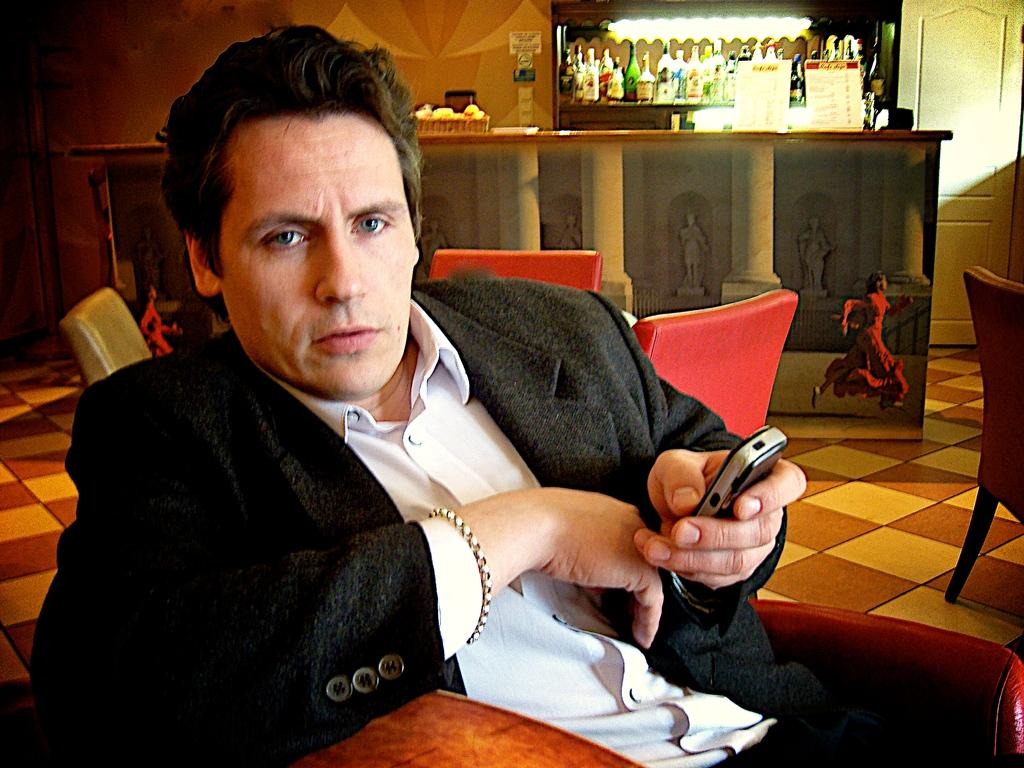What is the man in the image doing? The man is sitting on a sofa in the image. What is the man holding in his hand? The man is holding a mobile in his hand. What can be seen in the background of the image? There are empty chairs, a wall, and a table visible in the background of the image. What is on the table in the background? There is a group of bottles on the table. What type of lock is the minister using to secure his knowledge in the image? There is no lock, minister, or knowledge present in the image. 